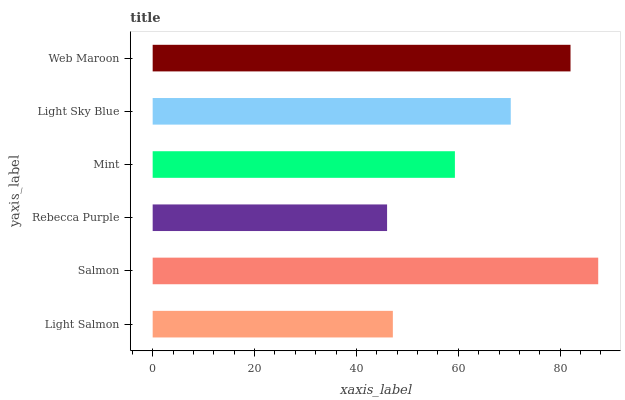Is Rebecca Purple the minimum?
Answer yes or no. Yes. Is Salmon the maximum?
Answer yes or no. Yes. Is Salmon the minimum?
Answer yes or no. No. Is Rebecca Purple the maximum?
Answer yes or no. No. Is Salmon greater than Rebecca Purple?
Answer yes or no. Yes. Is Rebecca Purple less than Salmon?
Answer yes or no. Yes. Is Rebecca Purple greater than Salmon?
Answer yes or no. No. Is Salmon less than Rebecca Purple?
Answer yes or no. No. Is Light Sky Blue the high median?
Answer yes or no. Yes. Is Mint the low median?
Answer yes or no. Yes. Is Salmon the high median?
Answer yes or no. No. Is Rebecca Purple the low median?
Answer yes or no. No. 